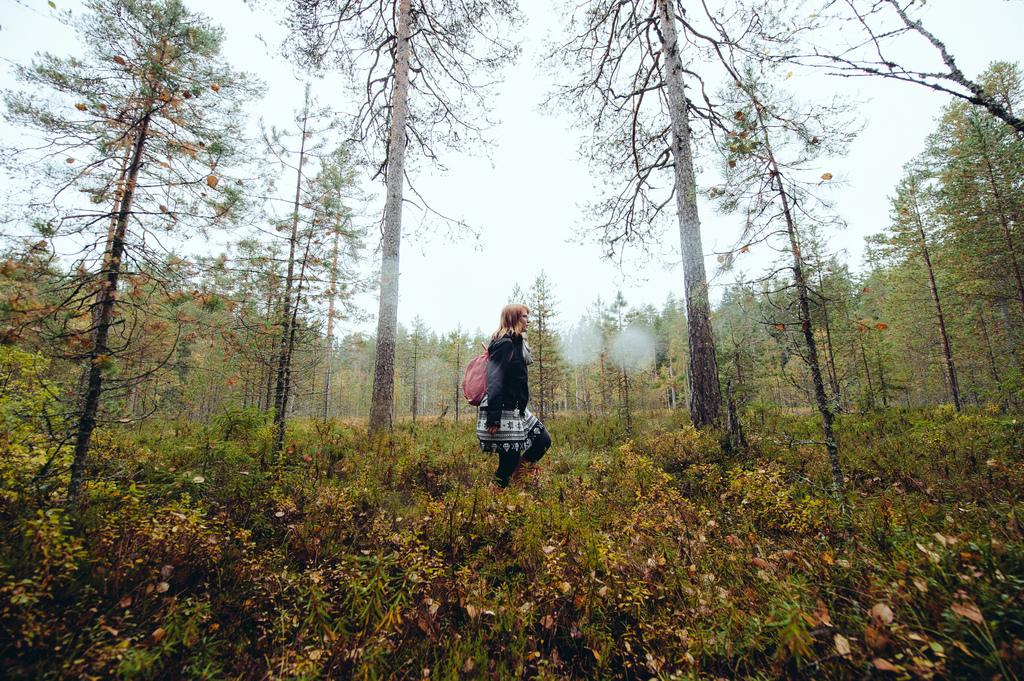What is in the foreground of the image? There are plants in the foreground of the image. What is the woman in the image doing? A woman is walking on the plants. What can be seen in the background of the image? There are trees in the background of the image. What type of straw is the woman using to sit comfortably on the plants? There is no straw present in the image, and the woman is walking on the plants, not sitting on them. How much time has passed since the woman started walking on the plants? The image does not provide any information about the duration of the woman's actions. 